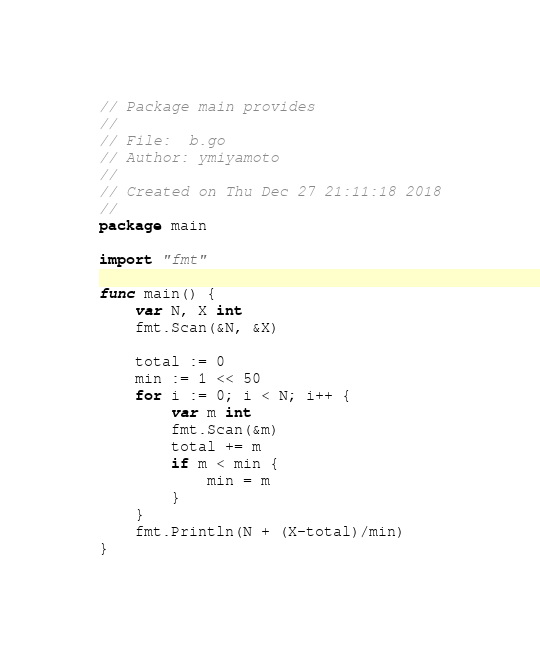Convert code to text. <code><loc_0><loc_0><loc_500><loc_500><_Go_>// Package main provides
//
// File:  b.go
// Author: ymiyamoto
//
// Created on Thu Dec 27 21:11:18 2018
//
package main

import "fmt"

func main() {
	var N, X int
	fmt.Scan(&N, &X)

	total := 0
	min := 1 << 50
	for i := 0; i < N; i++ {
		var m int
		fmt.Scan(&m)
		total += m
		if m < min {
			min = m
		}
	}
	fmt.Println(N + (X-total)/min)
}
</code> 